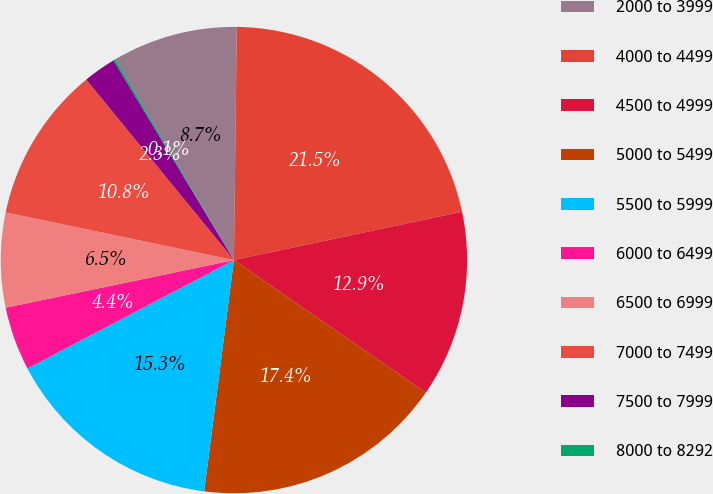Convert chart to OTSL. <chart><loc_0><loc_0><loc_500><loc_500><pie_chart><fcel>2000 to 3999<fcel>4000 to 4499<fcel>4500 to 4999<fcel>5000 to 5499<fcel>5500 to 5999<fcel>6000 to 6499<fcel>6500 to 6999<fcel>7000 to 7499<fcel>7500 to 7999<fcel>8000 to 8292<nl><fcel>8.68%<fcel>21.48%<fcel>12.95%<fcel>17.41%<fcel>15.27%<fcel>4.42%<fcel>6.55%<fcel>10.81%<fcel>2.28%<fcel>0.15%<nl></chart> 